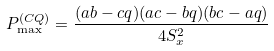<formula> <loc_0><loc_0><loc_500><loc_500>P _ { \max } ^ { ( C Q ) } = \frac { ( a b - c q ) ( a c - b q ) ( b c - a q ) } { 4 S _ { x } ^ { 2 } }</formula> 